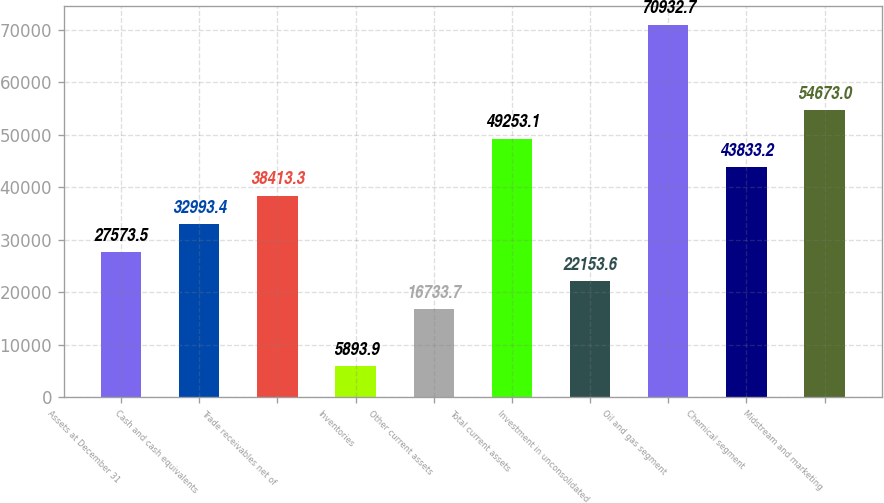<chart> <loc_0><loc_0><loc_500><loc_500><bar_chart><fcel>Assets at December 31<fcel>Cash and cash equivalents<fcel>Trade receivables net of<fcel>Inventories<fcel>Other current assets<fcel>Total current assets<fcel>Investment in unconsolidated<fcel>Oil and gas segment<fcel>Chemical segment<fcel>Midstream and marketing<nl><fcel>27573.5<fcel>32993.4<fcel>38413.3<fcel>5893.9<fcel>16733.7<fcel>49253.1<fcel>22153.6<fcel>70932.7<fcel>43833.2<fcel>54673<nl></chart> 